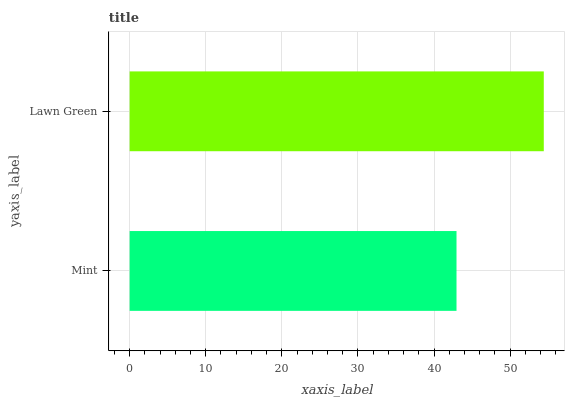Is Mint the minimum?
Answer yes or no. Yes. Is Lawn Green the maximum?
Answer yes or no. Yes. Is Lawn Green the minimum?
Answer yes or no. No. Is Lawn Green greater than Mint?
Answer yes or no. Yes. Is Mint less than Lawn Green?
Answer yes or no. Yes. Is Mint greater than Lawn Green?
Answer yes or no. No. Is Lawn Green less than Mint?
Answer yes or no. No. Is Lawn Green the high median?
Answer yes or no. Yes. Is Mint the low median?
Answer yes or no. Yes. Is Mint the high median?
Answer yes or no. No. Is Lawn Green the low median?
Answer yes or no. No. 